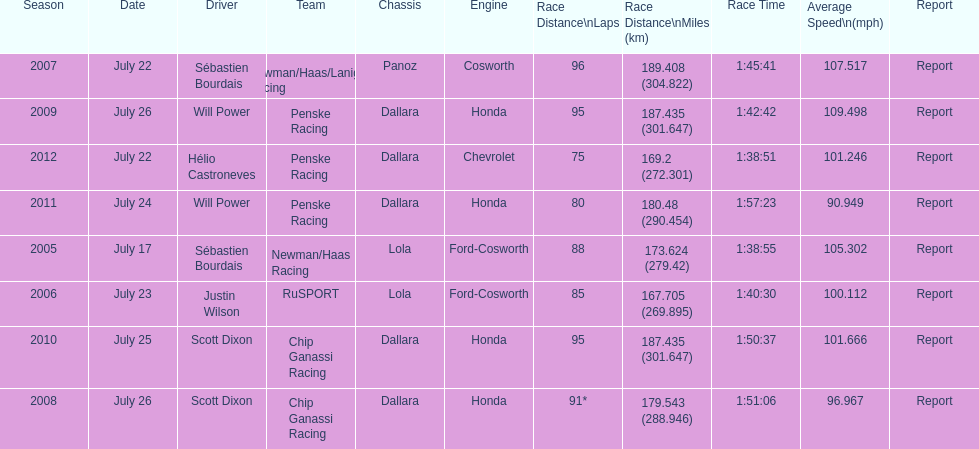How many different teams are represented in the table? 4. 